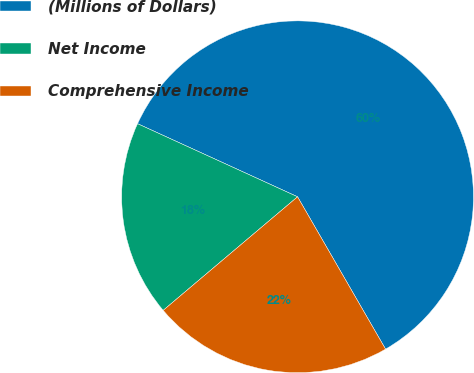<chart> <loc_0><loc_0><loc_500><loc_500><pie_chart><fcel>(Millions of Dollars)<fcel>Net Income<fcel>Comprehensive Income<nl><fcel>59.84%<fcel>17.99%<fcel>22.17%<nl></chart> 